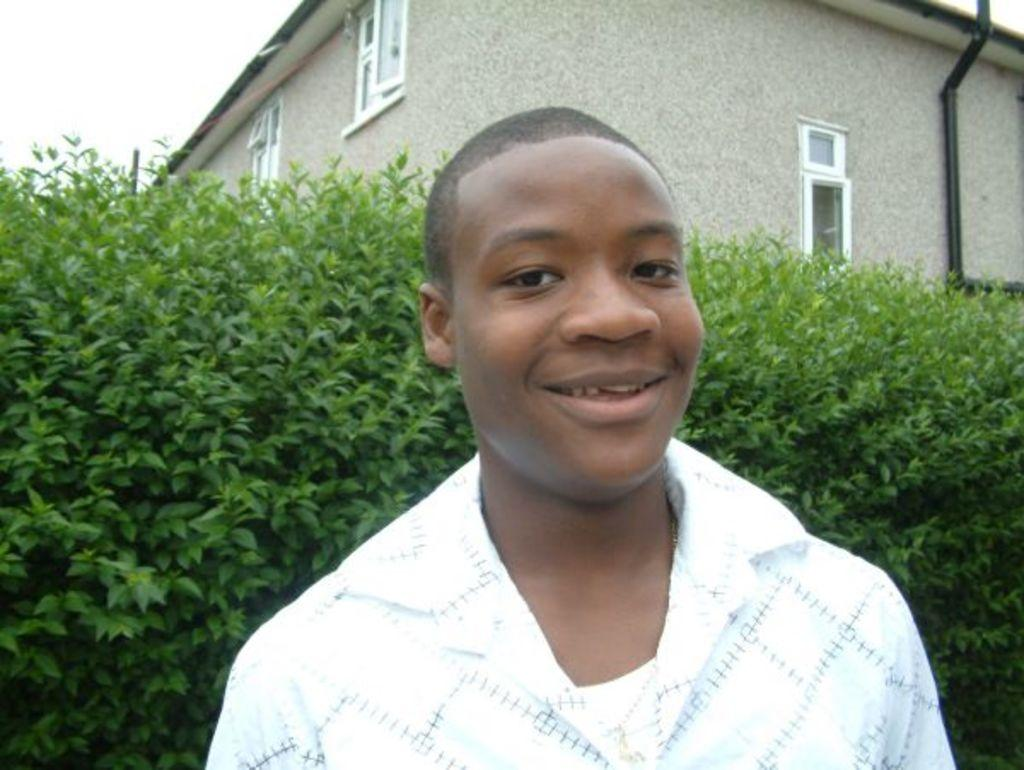What is the person in the image wearing? The person in the image is wearing a white shirt. What can be seen in the background of the image? In the background of the image, there are green trees, a gray building, and a white sky. Can you describe the color of the person's shirt? The person's shirt is white. What type of vegetation is visible in the background of the image? Green trees are visible in the background of the image. How many shelves are visible in the image? There are no shelves present in the image. What type of riddle can be solved by looking at the image? There is no riddle present in the image, so it cannot be solved by looking at it. 